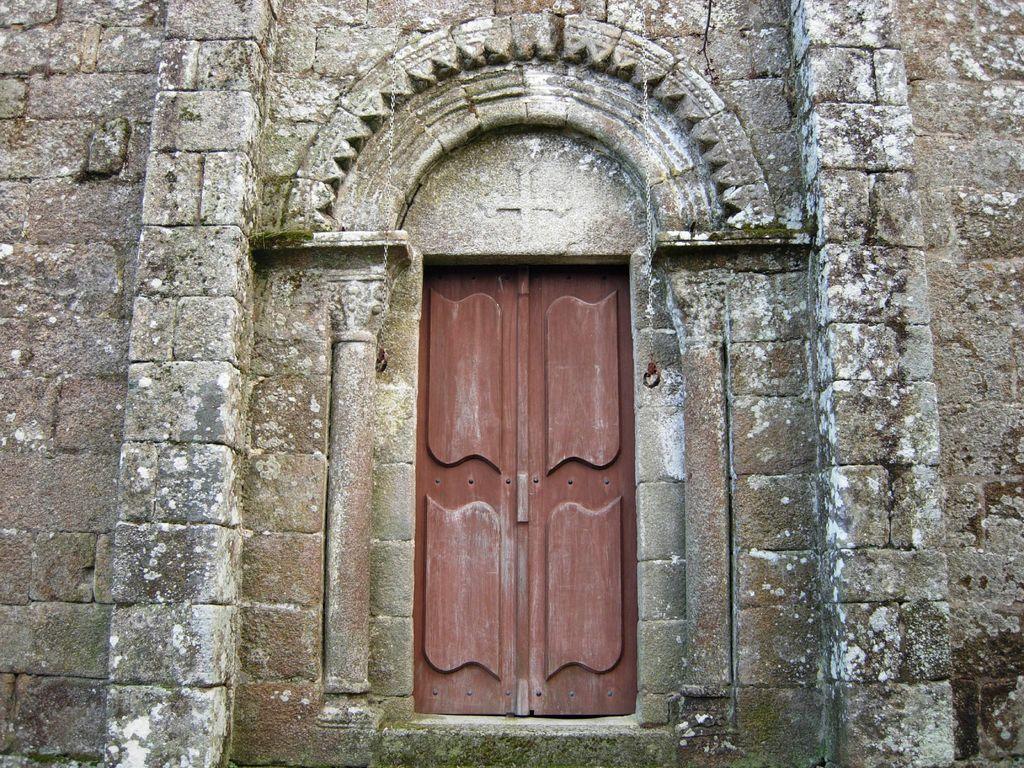How would you summarize this image in a sentence or two? In the image there is a door in between the wall and there is an arch above the door. 